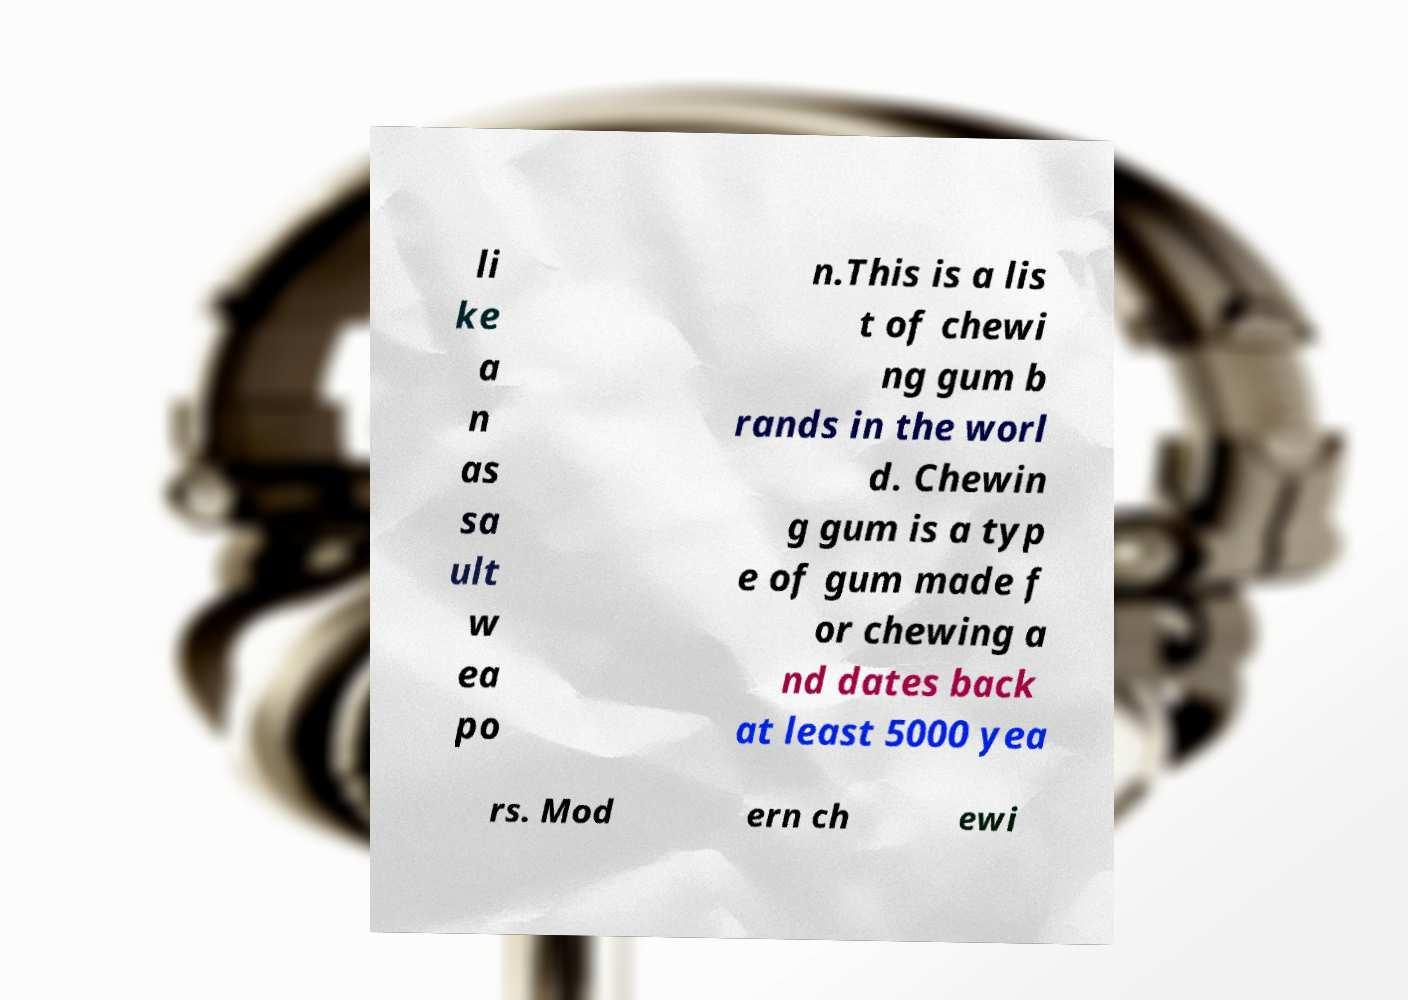I need the written content from this picture converted into text. Can you do that? li ke a n as sa ult w ea po n.This is a lis t of chewi ng gum b rands in the worl d. Chewin g gum is a typ e of gum made f or chewing a nd dates back at least 5000 yea rs. Mod ern ch ewi 